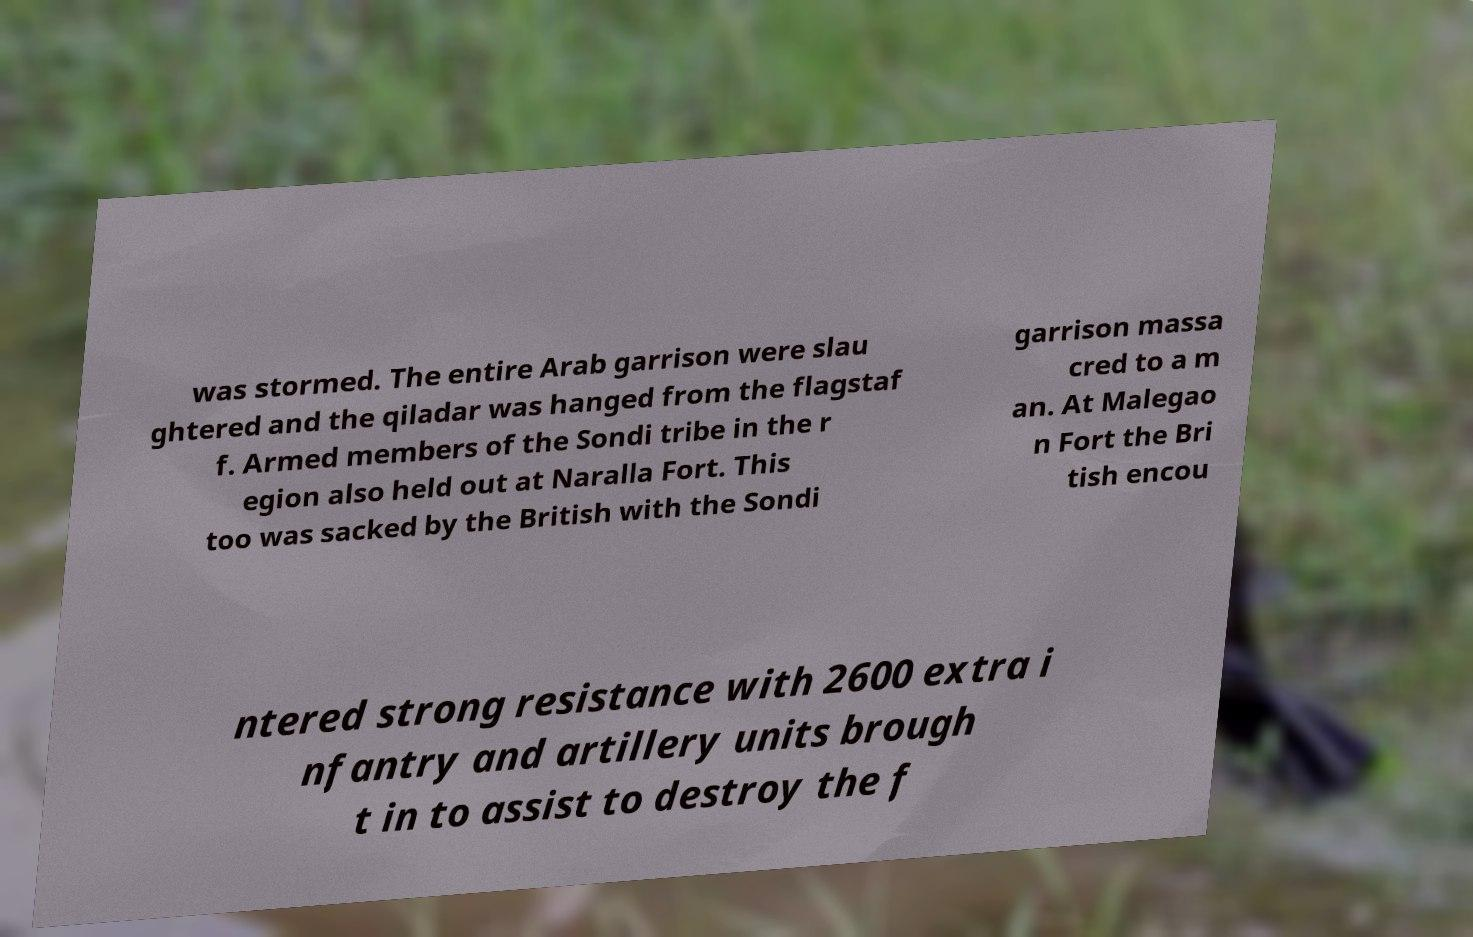I need the written content from this picture converted into text. Can you do that? was stormed. The entire Arab garrison were slau ghtered and the qiladar was hanged from the flagstaf f. Armed members of the Sondi tribe in the r egion also held out at Naralla Fort. This too was sacked by the British with the Sondi garrison massa cred to a m an. At Malegao n Fort the Bri tish encou ntered strong resistance with 2600 extra i nfantry and artillery units brough t in to assist to destroy the f 